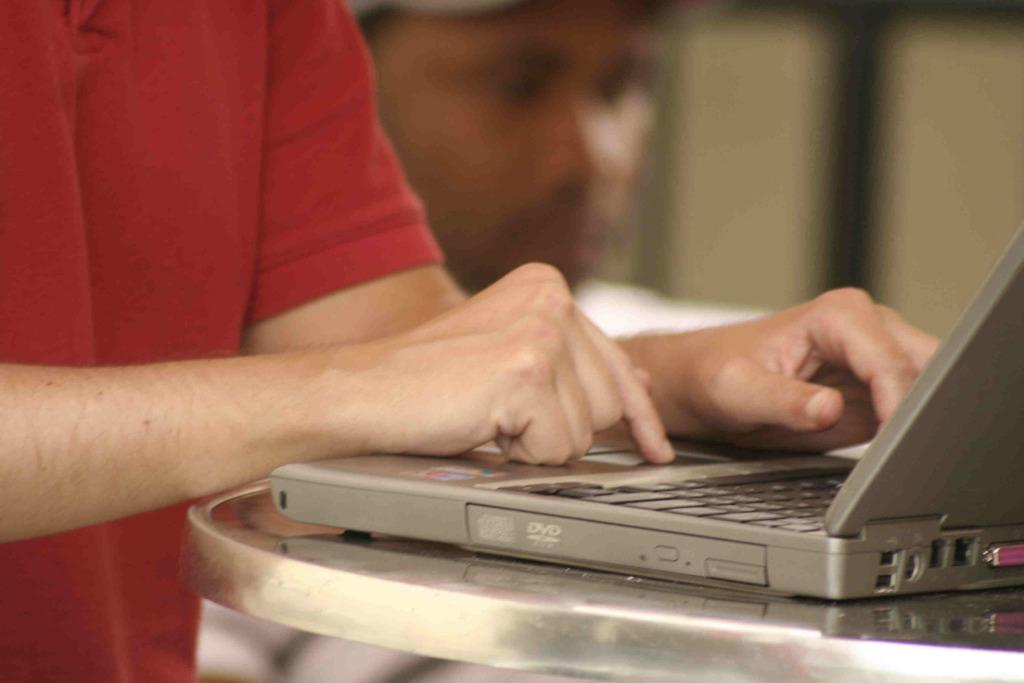What kind of slot is on the side of the laptop?
Give a very brief answer. Dvd. 